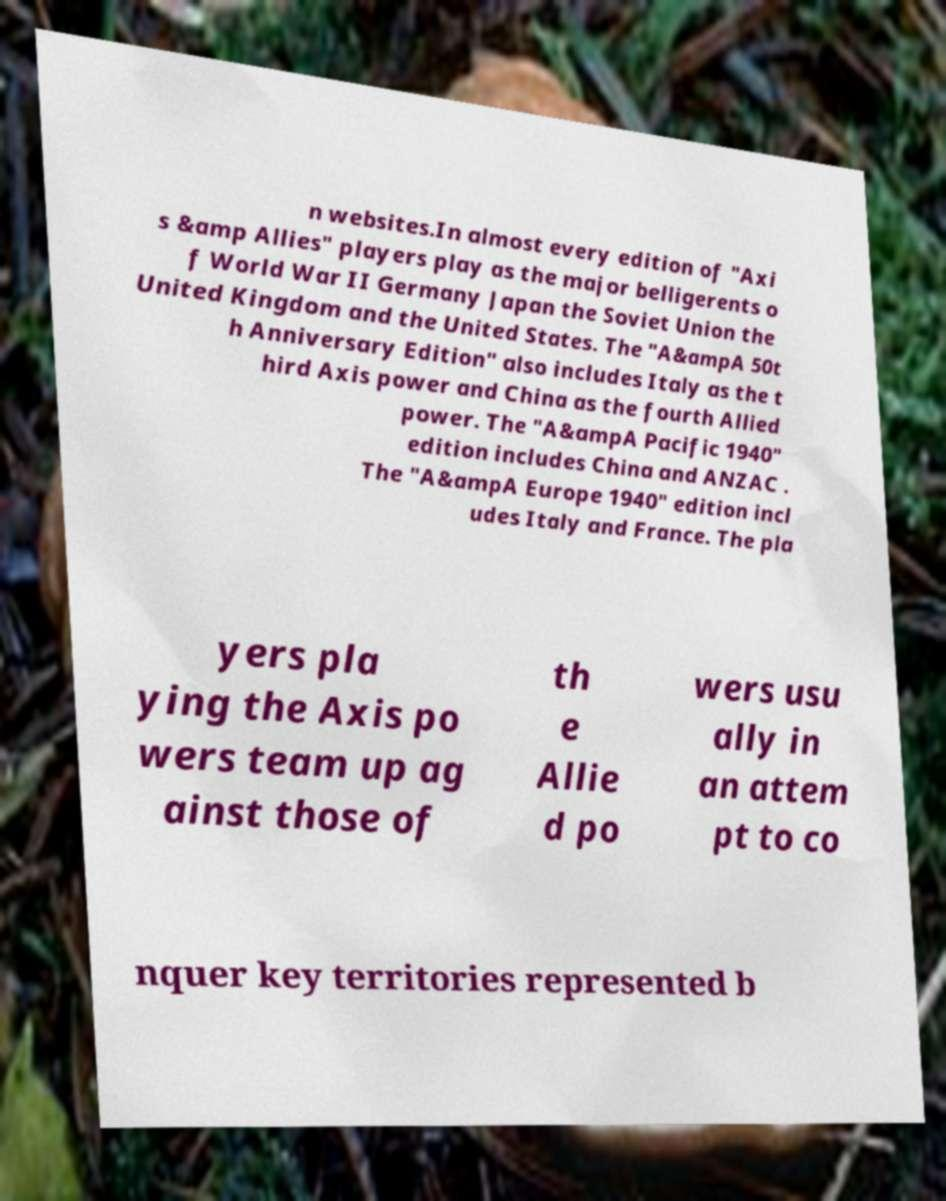There's text embedded in this image that I need extracted. Can you transcribe it verbatim? n websites.In almost every edition of "Axi s &amp Allies" players play as the major belligerents o f World War II Germany Japan the Soviet Union the United Kingdom and the United States. The "A&ampA 50t h Anniversary Edition" also includes Italy as the t hird Axis power and China as the fourth Allied power. The "A&ampA Pacific 1940" edition includes China and ANZAC . The "A&ampA Europe 1940" edition incl udes Italy and France. The pla yers pla ying the Axis po wers team up ag ainst those of th e Allie d po wers usu ally in an attem pt to co nquer key territories represented b 